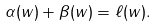<formula> <loc_0><loc_0><loc_500><loc_500>\alpha ( w ) + \beta ( w ) = \ell ( w ) .</formula> 